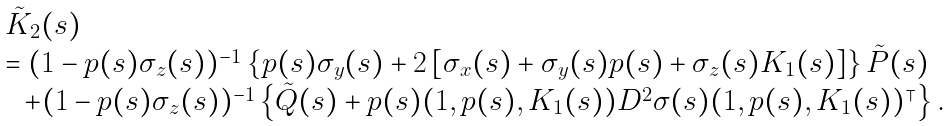<formula> <loc_0><loc_0><loc_500><loc_500>\begin{array} [ c ] { l l } & \tilde { K } _ { 2 } ( s ) \\ & = ( 1 - p ( s ) \sigma _ { z } ( s ) ) ^ { - 1 } \left \{ p ( s ) \sigma _ { y } ( s ) + 2 \left [ \sigma _ { x } ( s ) + \sigma _ { y } ( s ) p ( s ) + \sigma _ { z } ( s ) K _ { 1 } ( s ) \right ] \right \} \tilde { P } ( s ) \\ & \ \ + ( 1 - p ( s ) \sigma _ { z } ( s ) ) ^ { - 1 } \left \{ \tilde { Q } ( s ) + p ( s ) ( 1 , p ( s ) , K _ { 1 } ( s ) ) D ^ { 2 } \sigma ( s ) ( 1 , p ( s ) , K _ { 1 } ( s ) ) ^ { \intercal } \right \} . \end{array}</formula> 